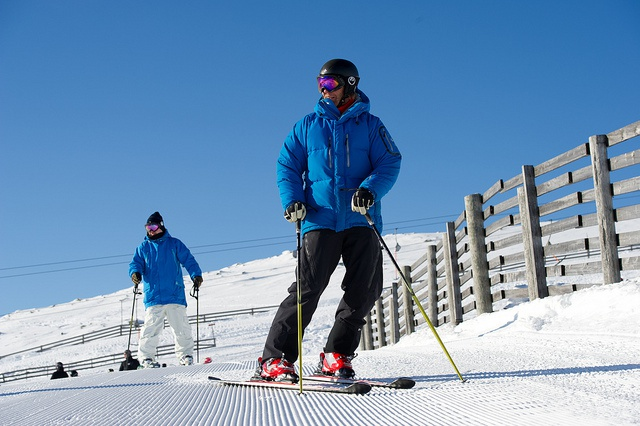Describe the objects in this image and their specific colors. I can see people in blue, black, navy, and teal tones, people in blue, darkgray, lightgray, and darkblue tones, skis in blue, white, black, gray, and darkgray tones, people in blue, black, gray, and purple tones, and people in blue, black, gray, darkgray, and purple tones in this image. 